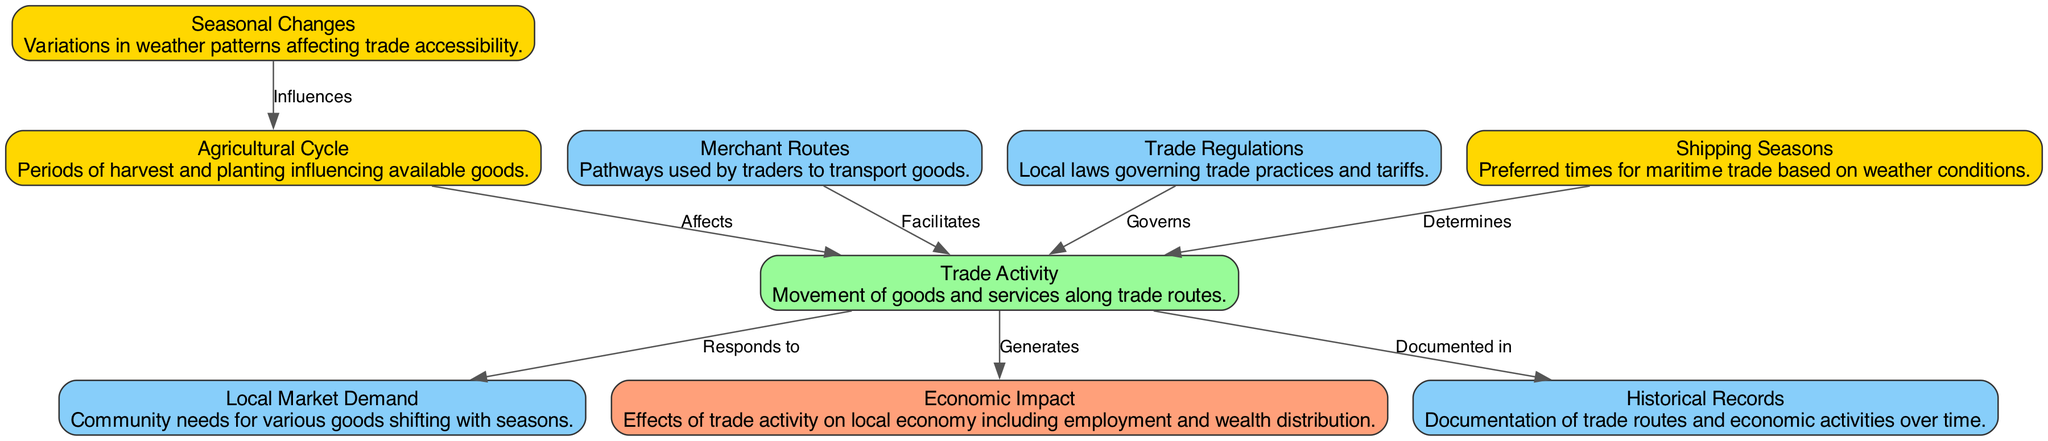What is the type of the "Agricultural Cycle" node? The "Agricultural Cycle" node is categorized as an event type in the diagram. This is evident from the node's description and its color code which indicates its classification.
Answer: event How many edges are present in the diagram? By counting each connection shown in the diagram, it is possible to determine that there are eight edges linking the various nodes.
Answer: eight Which event directly affects the "Trade Activity"? The "Agricultural Cycle" is directly connected to the "Trade Activity" node, indicating it as the influencing event on trade activities.
Answer: Agricultural Cycle What does the "Shipping Seasons" influence in the diagram? The "Shipping Seasons" node contributes to the "Trade Activity" by determining the appropriate times for maritime trade, which is clearly indicated by the directed edge connecting the two nodes.
Answer: Trade Activity What is the relationship between "Trade Activity" and "Economic Impact"? The relationship is that "Trade Activity" generates the "Economic Impact"; this is shown through an edge that connects the two nodes with a label "Generates".
Answer: Generates What type of entity governs the "Trade Activity"? The "Trade Regulations" node governs the "Trade Activity" in the diagram, as represented by the connecting edge labelled "Governs".
Answer: Trade Regulations How many unique events are shown in the diagram? The diagram features three unique events: "Seasonal Changes", "Agricultural Cycle", and "Shipping Seasons", which can be identified by examining the colored nodes labeled as events.
Answer: three What type is the "Local Market Demand" identified as? The "Local Market Demand" is classified as an entity type within the diagram based on its description and coloring, which corresponds to entities.
Answer: entity Which node is documented in "Historical Records"? The "Trade Activity" node is documented in the "Historical Records" according to the edge label that connects these two nodes in the diagram.
Answer: Trade Activity 